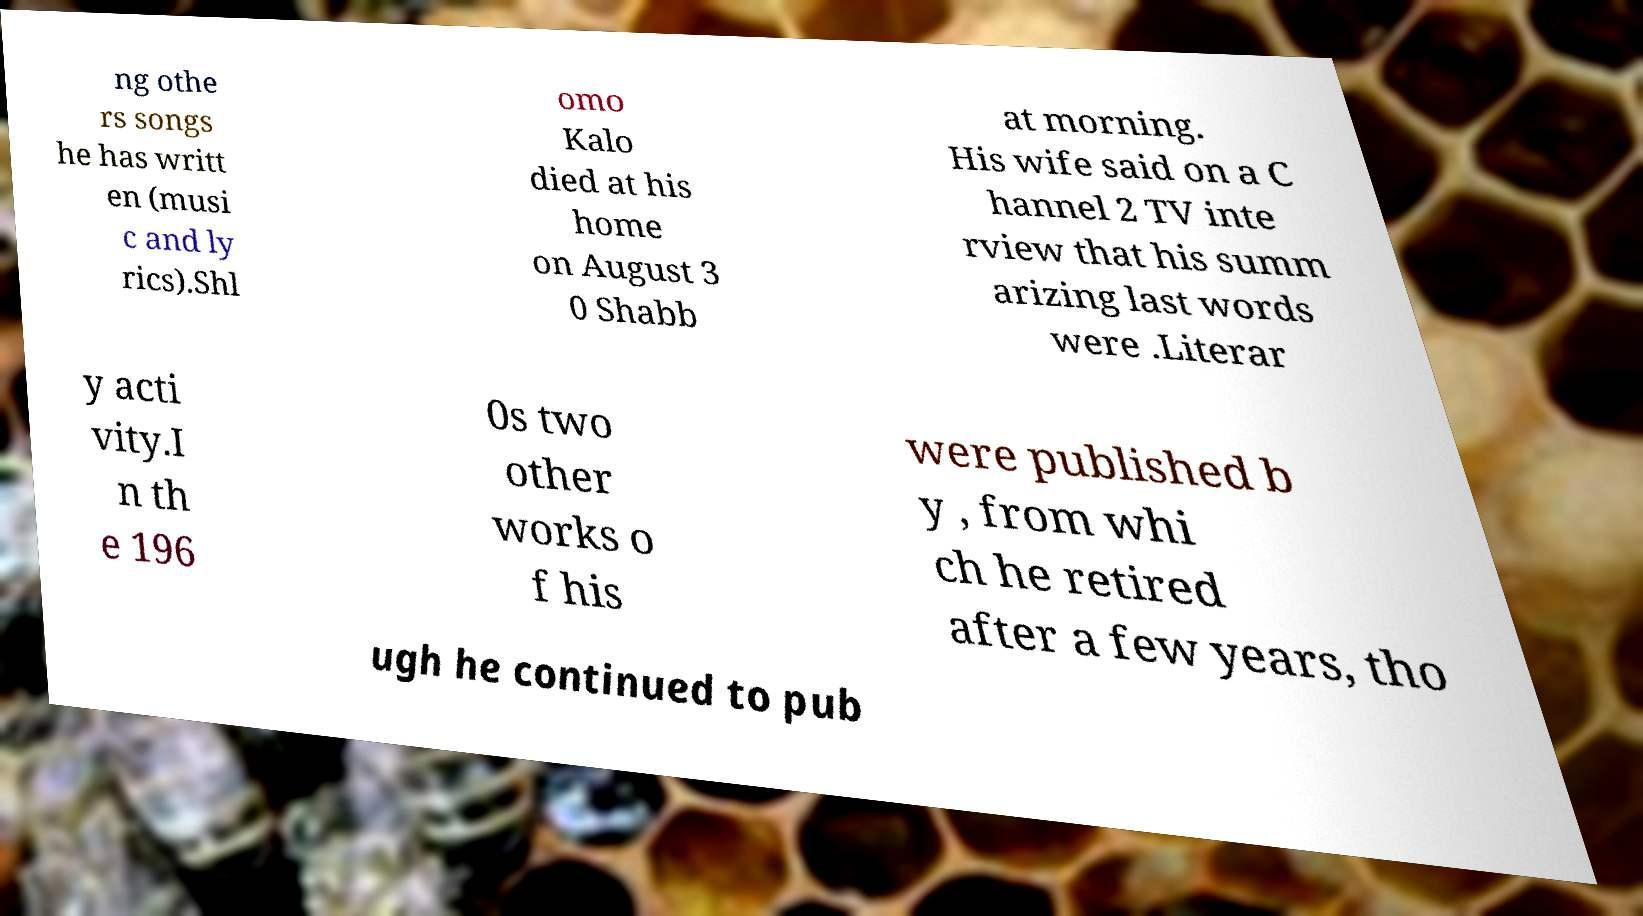Could you extract and type out the text from this image? ng othe rs songs he has writt en (musi c and ly rics).Shl omo Kalo died at his home on August 3 0 Shabb at morning. His wife said on a C hannel 2 TV inte rview that his summ arizing last words were .Literar y acti vity.I n th e 196 0s two other works o f his were published b y , from whi ch he retired after a few years, tho ugh he continued to pub 